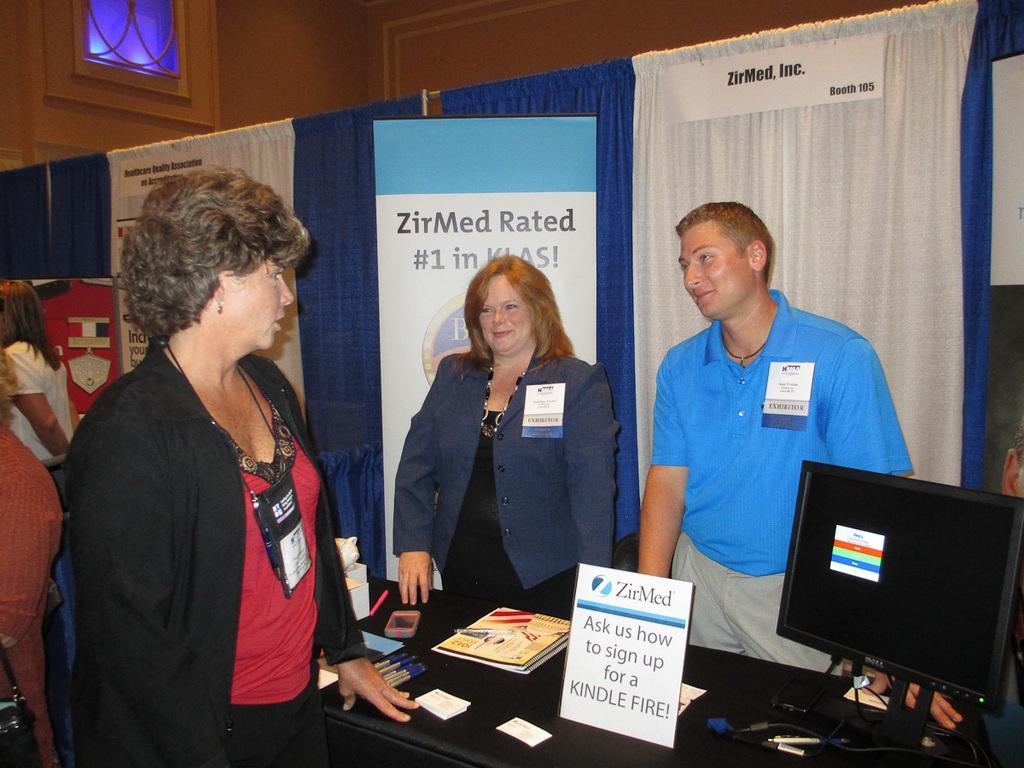Can you describe this image briefly? In this image I can see a woman wearing black and red colored dress is standing in front of a black colored desk and on the desk I can see few pens, few books, a board and a monitor. On the other side of the desk I can see a woman wearing blue and black colored dress and a man wearing grey and blue colored dress are standing. In the background I can see the blue and white colored curtains, the banner, few persons standing, the wall and the window. 